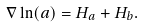Convert formula to latex. <formula><loc_0><loc_0><loc_500><loc_500>\nabla \ln ( a ) = H _ { a } + H _ { b } .</formula> 